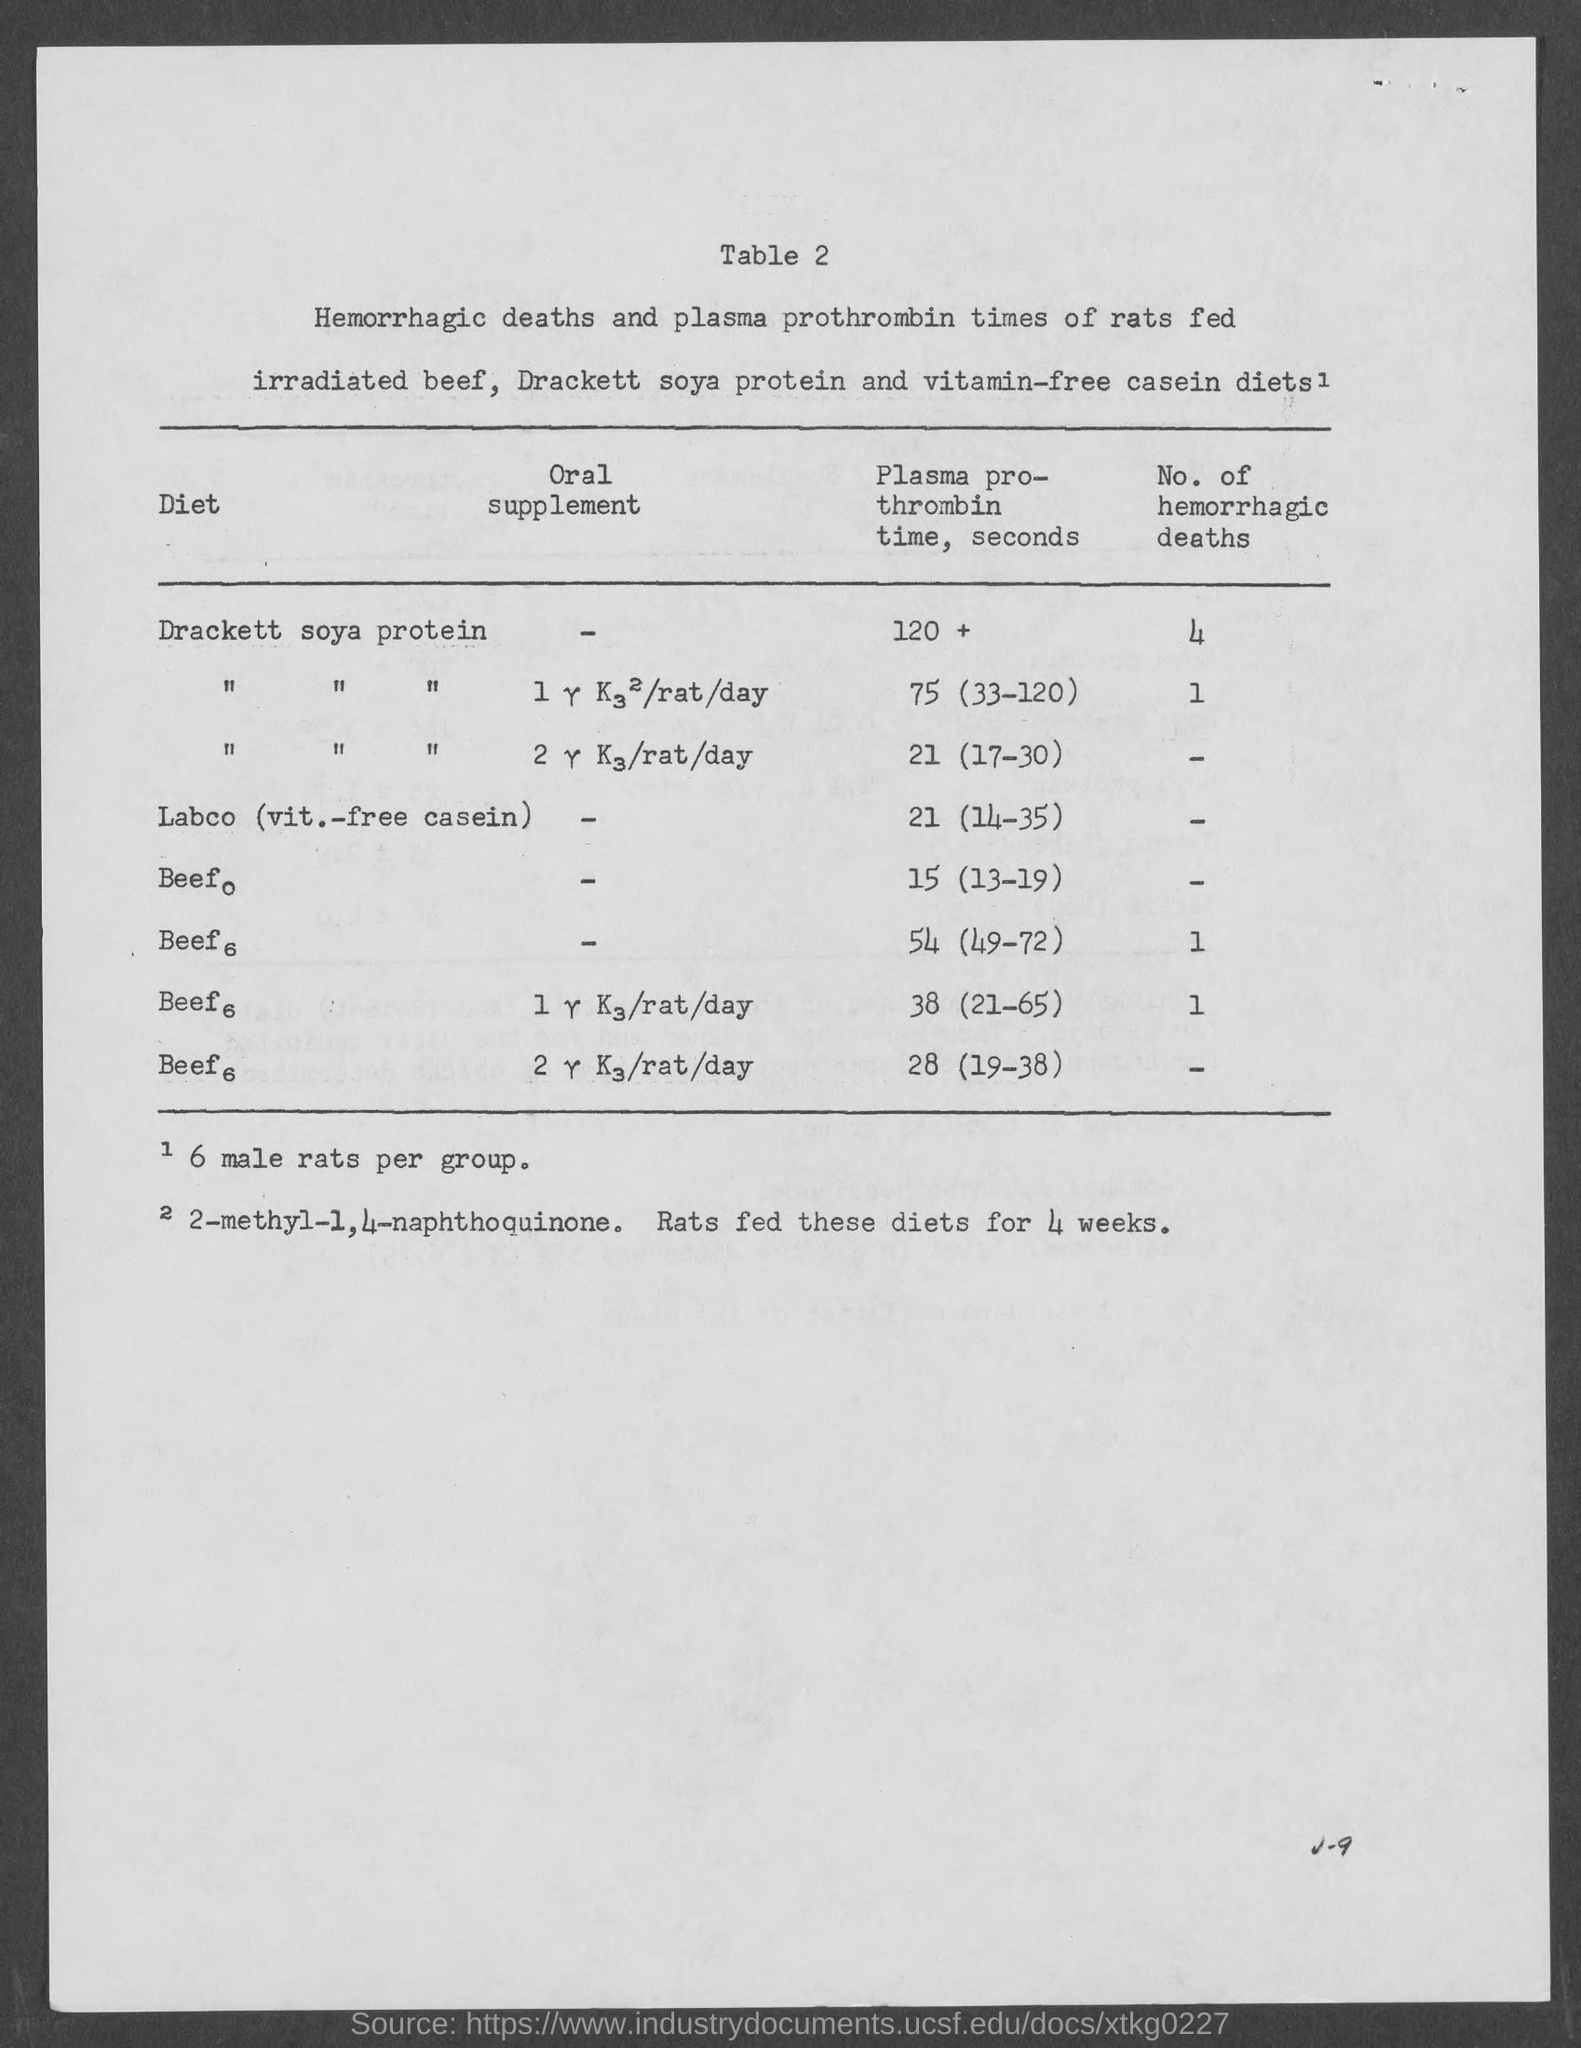Mention a couple of crucial points in this snapshot. According to records, there have been at least 4 reported cases of hemorrhagic deaths resulting from the use of Drackett's soya protein. The table number is two. The table is labeled as Table 2. The title of the first column of the table is 'diet.' 